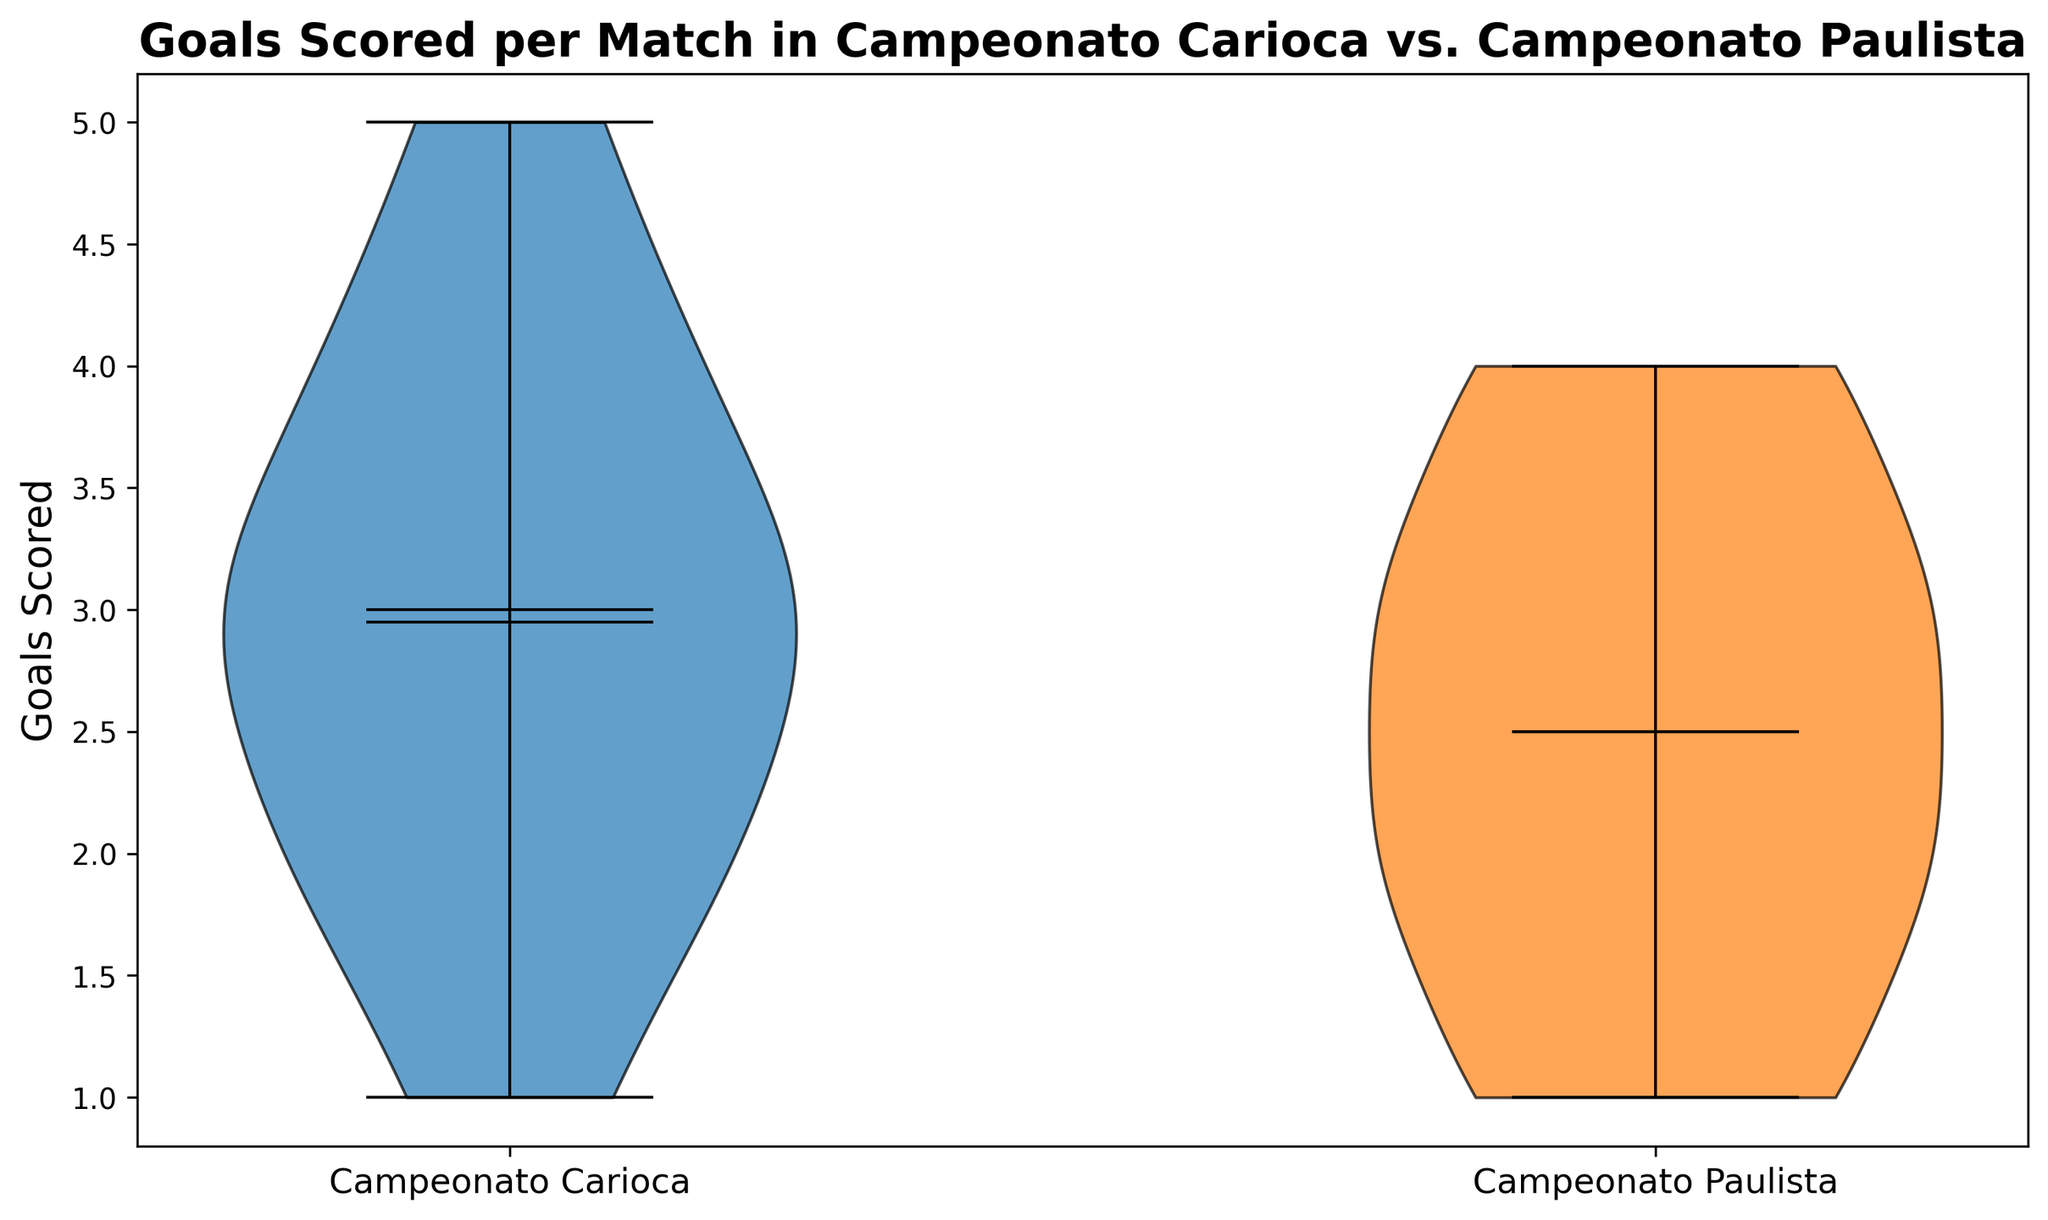What's the median value of goals scored in Campeonato Carioca? To find the median, we need to sort the goals scored in Campeonato Carioca and find the middle value. In this case, the sorted values are [1, 1, 2, 2, 2, 2, 2, 2, 3, 3, 3, 3, 3, 3, 4, 4, 4, 4, 5, 5]. With an even number of data points (20), we take the average of the 10th and 11th values: (3+3)/2 = 3.
Answer: 3 What's the median value of goals scored in Campeonato Paulista? To find the median, we sort the values for Campeonato Paulista: [1, 1, 1, 1, 2, 2, 2, 2, 2, 2, 3, 3, 3, 3, 3, 3, 4, 4, 4, 4]. With an even number of data points (20), we take the average of the 10th and 11th values: (2+3)/2 = 2.5.
Answer: 2.5 Which tournament has a higher mean value of goals scored per match? The mean value can be found by summing all goals for each tournament and dividing by the number of matches. For Campeonato Carioca: (3+2+4+1+3+5+2+4+3+2+3+4+1+3+5+2+4+3+2+3) / 20 = 3. To check for Campeonato Paulista: (2+1+3+2+4+1+3+2+4+3+2+1+3+2+4+1+3+2+4+3) / 20 = 2.6. Campeonato Carioca has the higher mean.
Answer: Campeonato Carioca What is the range of goals scored in Campeonato Carioca? The range is determined by the difference between the highest and lowest values in the data set. For Campeonato Carioca, the highest value is 5 and the lowest is 1, so the range is 5 - 1 = 4.
Answer: 4 What is the interquartile range (IQR) for goals scored in Campeonato Paulista? The IQR is the difference between the third quartile (Q3) and the first quartile (Q1). For the sorted data of Campeonato Paulista: [1, 1, 1, 1, 2, 2, 2, 2, 2, 2, 3, 3, 3, 3, 3, 3, 4, 4, 4, 4], Q1 is 2 (the middle value of the first half) and Q3 is 3 (the middle value of the second half), so IQR = 3 - 2 = 1.
Answer: 1 Which tournament shows more variability in the goals scored per match? Variability can be inferred from the spread of the data and the width of the violin plot. Campeonato Carioca has a wider spread with values ranging from 1 to 5, whereas Campeonato Paulista ranges from 1 to 4. This suggests more variability in Campeonato Carioca.
Answer: Campeonato Carioca What is the skewness of goals scored distribution in Campeonato Carioca? To determine skewness from a violin plot, we look at the symmetry and whether the tail on one side of the mean is longer. If one tail is longer, it suggests skewness in that direction. The Campeonato Carioca distribution looks slightly skewed to the right as there is a longer tail towards higher goal counts (4 and 5).
Answer: Right-skewed What is the mode of the goals scored in Campeonato Paulista? The mode is the most frequently occurring value. For Campeonato Paulista, from the list [1, 1, 1, 1, 2, 2, 2, 2, 2, 2, 3, 3, 3, 3, 3, 3, 4, 4, 4, 4], the most frequent values are 2 and 3, both appearing 6 times each.
Answer: 2 and 3 